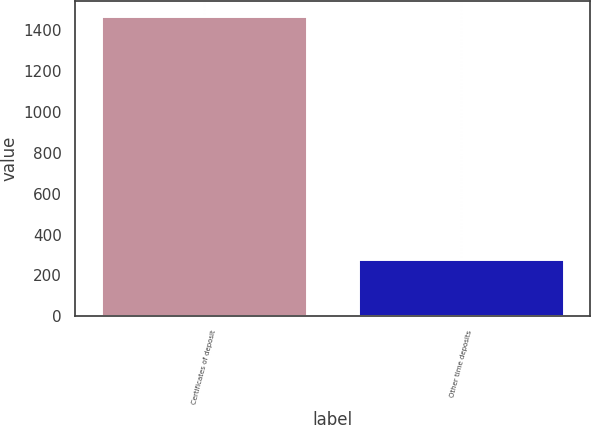Convert chart. <chart><loc_0><loc_0><loc_500><loc_500><bar_chart><fcel>Certificates of deposit<fcel>Other time deposits<nl><fcel>1471<fcel>280<nl></chart> 